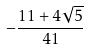Convert formula to latex. <formula><loc_0><loc_0><loc_500><loc_500>- \frac { 1 1 + 4 \sqrt { 5 } } { 4 1 }</formula> 